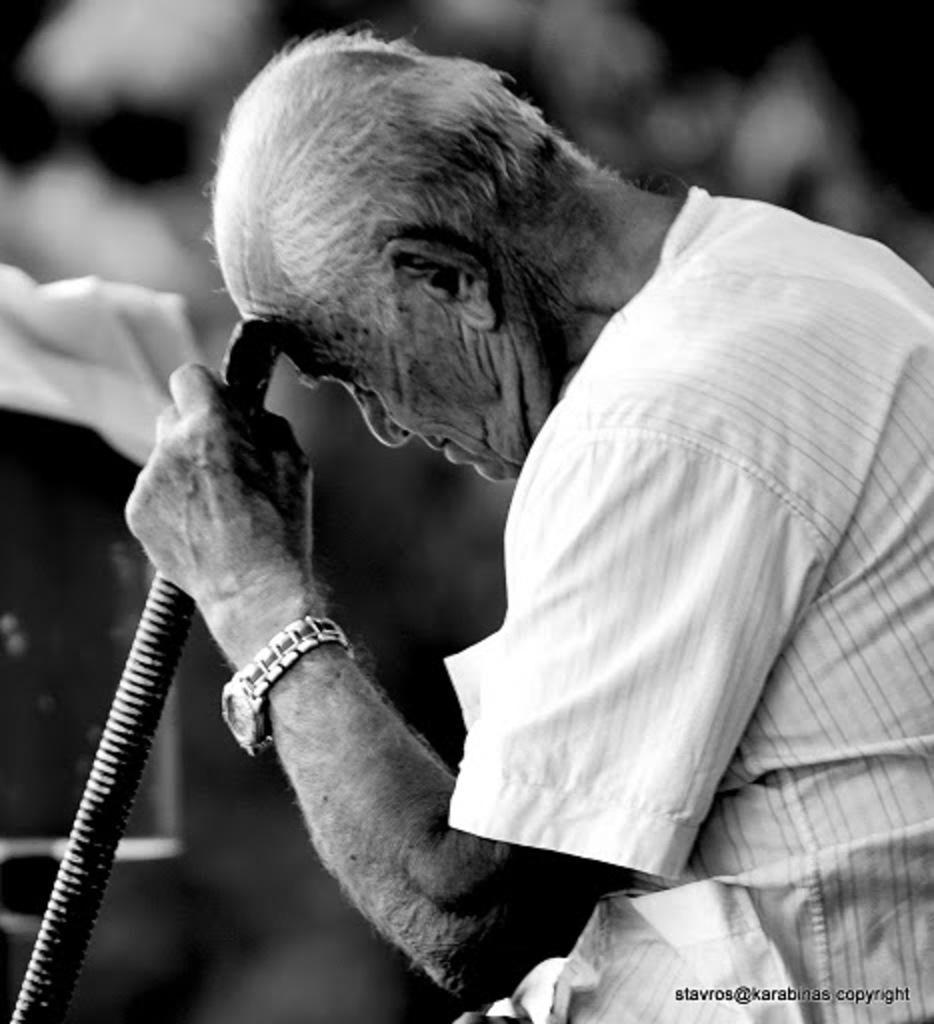How would you summarize this image in a sentence or two? As we can see in the image in the front there is a man wearing white color shirt, watch and holding a stick. The background is dark. 